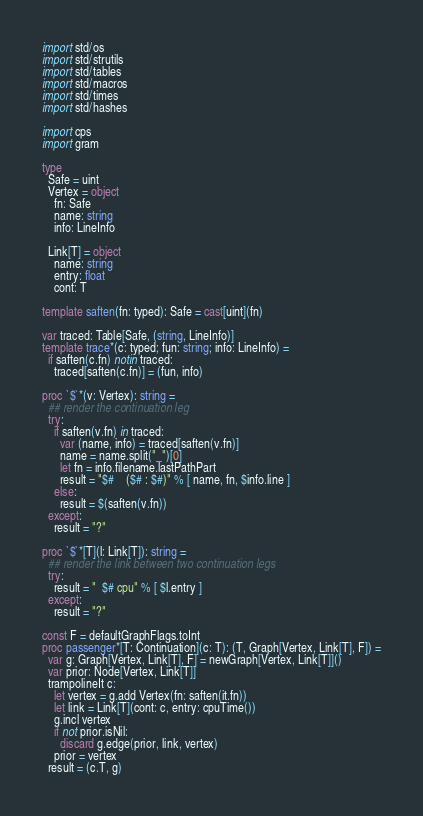Convert code to text. <code><loc_0><loc_0><loc_500><loc_500><_Nim_>import std/os
import std/strutils
import std/tables
import std/macros
import std/times
import std/hashes

import cps
import gram

type
  Safe = uint
  Vertex = object
    fn: Safe
    name: string
    info: LineInfo

  Link[T] = object
    name: string
    entry: float
    cont: T

template saften(fn: typed): Safe = cast[uint](fn)

var traced: Table[Safe, (string, LineInfo)]
template trace*(c: typed; fun: string; info: LineInfo) =
  if saften(c.fn) notin traced:
    traced[saften(c.fn)] = (fun, info)

proc `$`*(v: Vertex): string =
  ## render the continuation leg
  try:
    if saften(v.fn) in traced:
      var (name, info) = traced[saften(v.fn)]
      name = name.split("_")[0]
      let fn = info.filename.lastPathPart
      result = "$#    ($# : $#)" % [ name, fn, $info.line ]
    else:
      result = $(saften(v.fn))
  except:
    result = "?"

proc `$`*[T](l: Link[T]): string =
  ## render the link between two continuation legs
  try:
    result = "  $# cpu" % [ $l.entry ]
  except:
    result = "?"

const F = defaultGraphFlags.toInt
proc passenger*[T: Continuation](c: T): (T, Graph[Vertex, Link[T], F]) =
  var g: Graph[Vertex, Link[T], F] = newGraph[Vertex, Link[T]]()
  var prior: Node[Vertex, Link[T]]
  trampolineIt c:
    let vertex = g.add Vertex(fn: saften(it.fn))
    let link = Link[T](cont: c, entry: cpuTime())
    g.incl vertex
    if not prior.isNil:
      discard g.edge(prior, link, vertex)
    prior = vertex
  result = (c.T, g)
</code> 